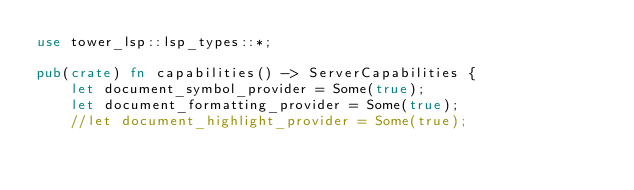Convert code to text. <code><loc_0><loc_0><loc_500><loc_500><_Rust_>use tower_lsp::lsp_types::*;

pub(crate) fn capabilities() -> ServerCapabilities {
	let document_symbol_provider = Some(true);
	let document_formatting_provider = Some(true);
	//let document_highlight_provider = Some(true);
</code> 